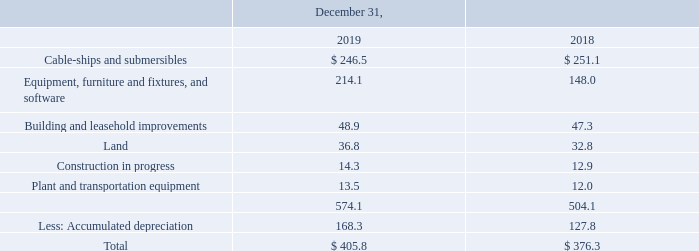Property, plant and equipment consists of the following (in millions):
Depreciation expense was $52.3 million and $46.6 million for the years ended December 31, 2019 and 2018, respectively. These amounts included $9.1 million and $7.0 million of depreciation expense recognized within cost of revenue for the years ended December 31, 2019 and 2018, respectively.
As of December 31, 2019 and 2018 total net book value of equipment, cable-ships, and submersibles under capital leases consisted of $35.1 million and $40.0 million, respectively.
For the year ended December 31, 2018, our Energy segment recorded an impairment expense of $0.7 million, of which $0.4 million was due to station performance and $0.3 million was related to the abandonment of a station development project.
What was the depreciation expense in 2019? $52.3 million. What is the count of depreciable assets in the company? 6. What was the impairment expense for Energy segment in 2018? $0.7 million. What is the increase / (decrease) in the Cable-ships and submersibles from 2018 to 2019?
Answer scale should be: million. 246.5 - 251.1
Answer: -4.6. What is the average Equipment, furniture and fixtures, and software?
Answer scale should be: million. (214.1 + 148.0) / 2
Answer: 181.05. What is the average Building and leasehold improvements?
Answer scale should be: million. (48.9 + 47.3) / 2
Answer: 48.1. 